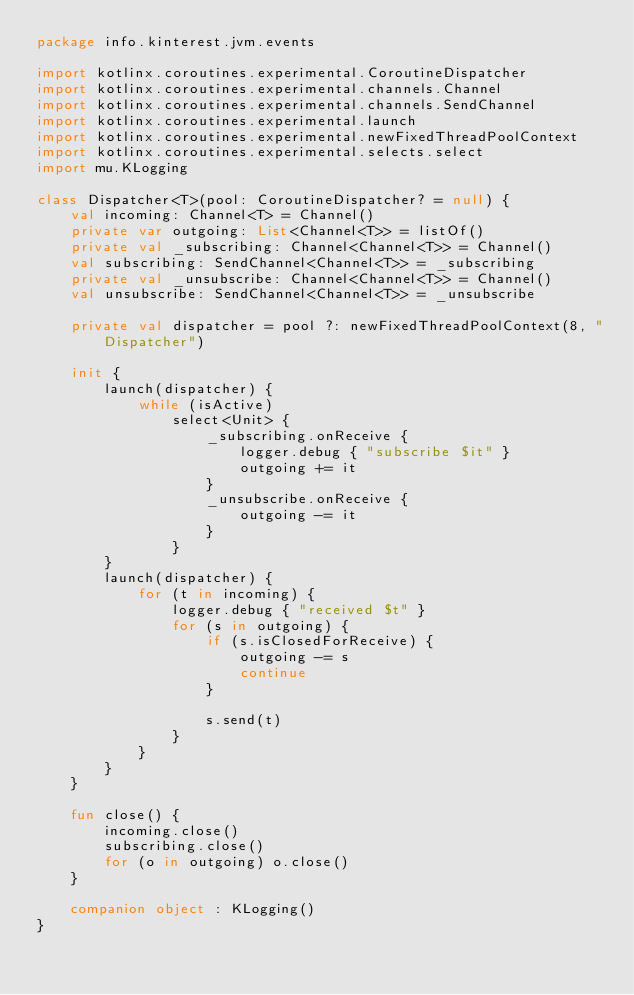Convert code to text. <code><loc_0><loc_0><loc_500><loc_500><_Kotlin_>package info.kinterest.jvm.events

import kotlinx.coroutines.experimental.CoroutineDispatcher
import kotlinx.coroutines.experimental.channels.Channel
import kotlinx.coroutines.experimental.channels.SendChannel
import kotlinx.coroutines.experimental.launch
import kotlinx.coroutines.experimental.newFixedThreadPoolContext
import kotlinx.coroutines.experimental.selects.select
import mu.KLogging

class Dispatcher<T>(pool: CoroutineDispatcher? = null) {
    val incoming: Channel<T> = Channel()
    private var outgoing: List<Channel<T>> = listOf()
    private val _subscribing: Channel<Channel<T>> = Channel()
    val subscribing: SendChannel<Channel<T>> = _subscribing
    private val _unsubscribe: Channel<Channel<T>> = Channel()
    val unsubscribe: SendChannel<Channel<T>> = _unsubscribe

    private val dispatcher = pool ?: newFixedThreadPoolContext(8, "Dispatcher")

    init {
        launch(dispatcher) {
            while (isActive)
                select<Unit> {
                    _subscribing.onReceive {
                        logger.debug { "subscribe $it" }
                        outgoing += it
                    }
                    _unsubscribe.onReceive {
                        outgoing -= it
                    }
                }
        }
        launch(dispatcher) {
            for (t in incoming) {
                logger.debug { "received $t" }
                for (s in outgoing) {
                    if (s.isClosedForReceive) {
                        outgoing -= s
                        continue
                    }

                    s.send(t)
                }
            }
        }
    }

    fun close() {
        incoming.close()
        subscribing.close()
        for (o in outgoing) o.close()
    }

    companion object : KLogging()
}
</code> 